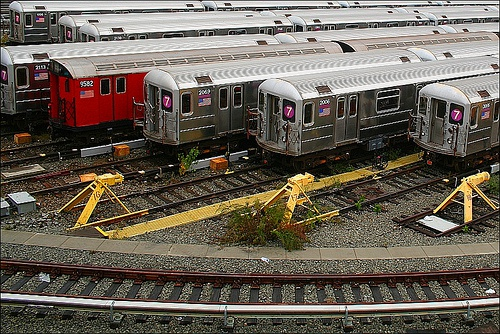Describe the objects in this image and their specific colors. I can see train in black, lightgray, darkgray, and gray tones, train in black, lightgray, darkgray, and gray tones, train in black, darkgray, and maroon tones, train in black, lightgray, darkgray, and gray tones, and train in black, gray, darkgray, and lightgray tones in this image. 